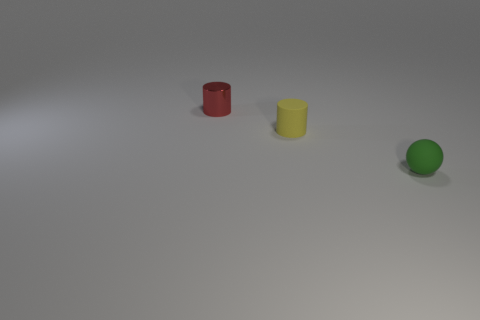Add 3 small balls. How many objects exist? 6 Subtract all spheres. How many objects are left? 2 Add 2 red objects. How many red objects are left? 3 Add 1 red objects. How many red objects exist? 2 Subtract 0 red cubes. How many objects are left? 3 Subtract all tiny yellow rubber objects. Subtract all tiny brown balls. How many objects are left? 2 